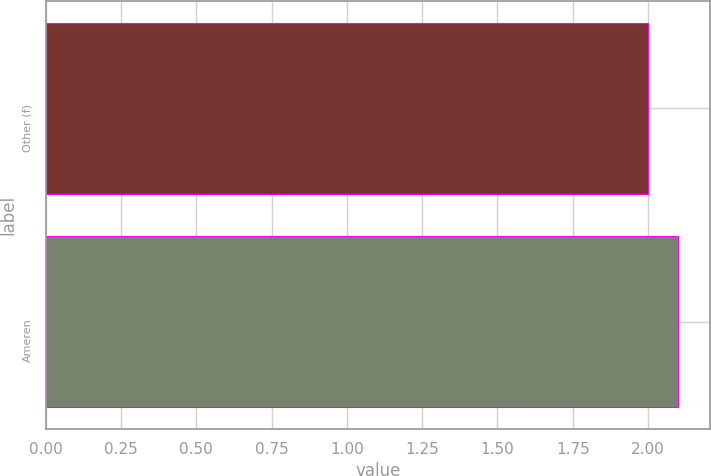Convert chart to OTSL. <chart><loc_0><loc_0><loc_500><loc_500><bar_chart><fcel>Other (f)<fcel>Ameren<nl><fcel>2<fcel>2.1<nl></chart> 